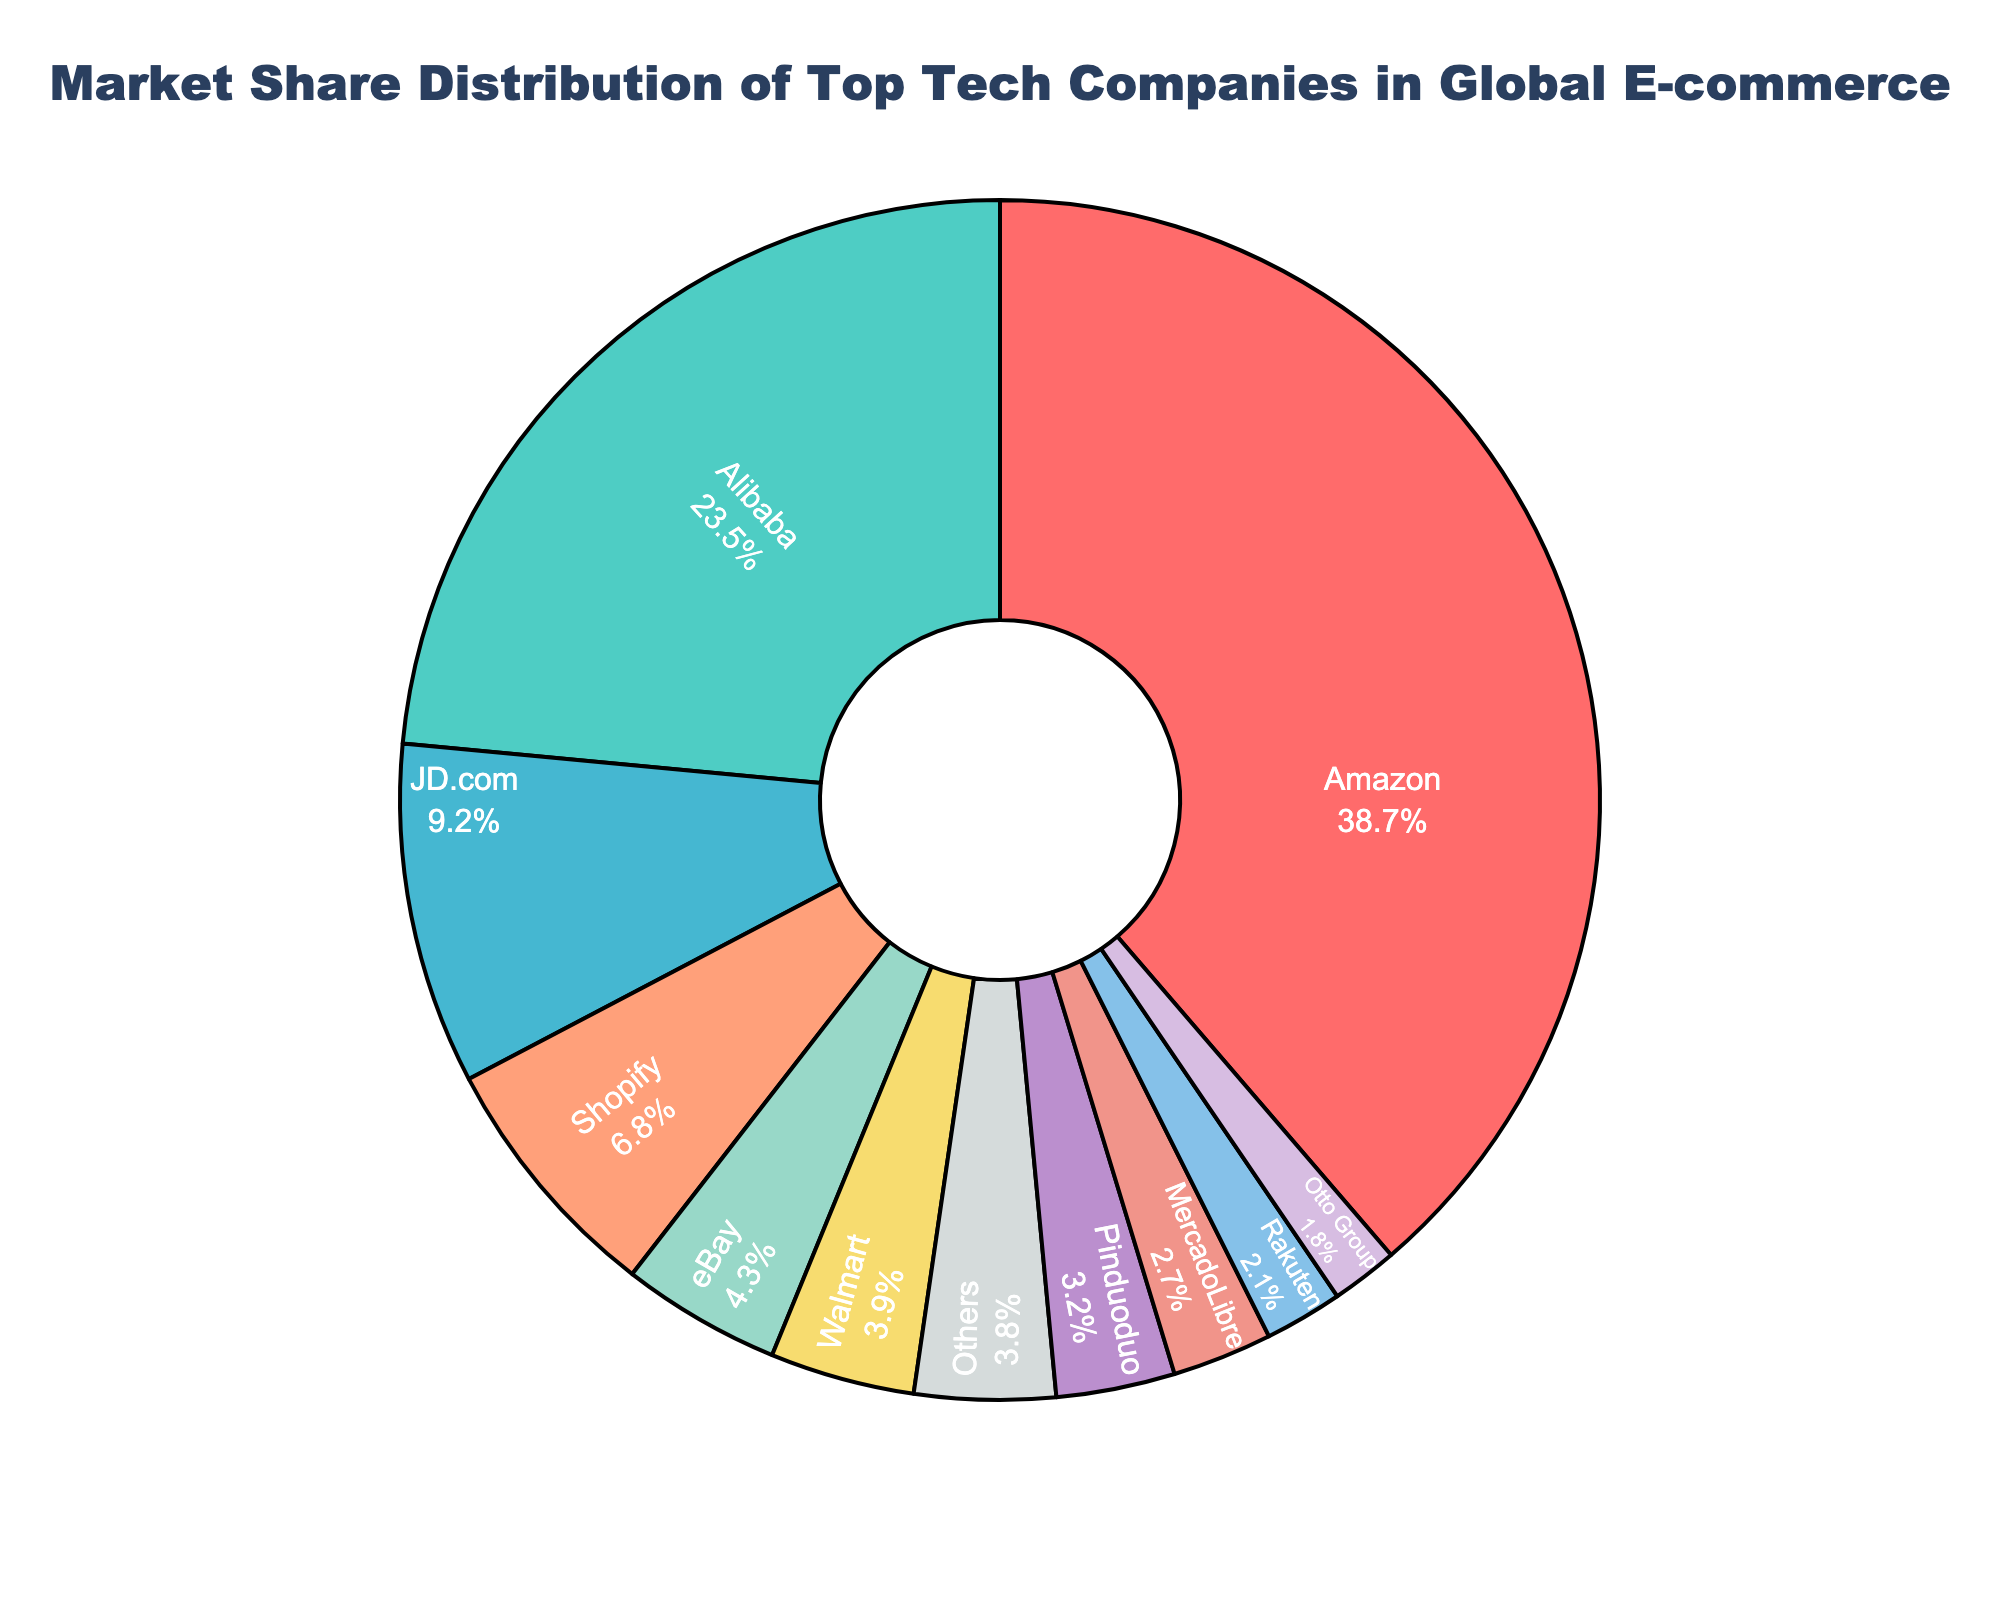Which company holds the largest market share in global e-commerce? Looking at the size of the slices in the pie chart, Amazon has the largest slice, indicating the highest market share.
Answer: Amazon What is the combined market share of JD.com, Shopify, and Pinduoduo? Add the market share percentages of JD.com (9.2%), Shopify (6.8%), and Pinduoduo (3.2%). The combined market share is 9.2 + 6.8 + 3.2 = 19.2%.
Answer: 19.2% How does eBay's market share compare to Walmart's market share? eBay's market share is 4.3%, while Walmart's market share is 3.9%. eBay's market share is marginally higher than Walmart's.
Answer: eBay has a higher market share than Walmart Is Alibaba's market share greater than the combined market share of MercadoLibre and Rakuten? Alibaba's market share is 23.5%. The combined market share of MercadoLibre (2.7%) and Rakuten (2.1%) is 4.8%. Alibaba's market share is significantly higher than the combined share of MercadoLibre and Rakuten.
Answer: Yes What is the market share of the companies categorized as 'Others'? The pie chart shows that 'Others' have a market share of 3.8%.
Answer: 3.8% What is the difference in market share between the largest company (Amazon) and the smallest company (Otto Group)? Amazon's market share is 38.7%, and Otto Group's market share is 1.8%. The difference is 38.7% - 1.8% = 36.9%.
Answer: 36.9% Which company has a smaller market share: Shopify or Pinduoduo? Shopify has a market share of 6.8%, whereas Pinduoduo has a market share of 3.2%. Therefore, Pinduoduo has a smaller market share than Shopify.
Answer: Pinduoduo What percentage of the market do the top three companies (Amazon, Alibaba, and JD.com) control? Add the market share percentages of Amazon (38.7%), Alibaba (23.5%), and JD.com (9.2%). The total market share controlled by the top three companies is 38.7% + 23.5% + 9.2% = 71.4%.
Answer: 71.4% Identify a company with a blue-colored slice in the pie chart and its market share. One of the blue-colored slices in the pie chart represents JD.com, which has a market share of 9.2%.
Answer: JD.com with 9.2% Compare the total market share of companies with a market share less than 3% to that of Walmart. Identify companies with <3% market share: MercadoLibre (2.7%), Rakuten (2.1%), Otto Group (1.8%). Their combined market share is 2.7% + 2.1% + 1.8% = 6.6%, which is greater than Walmart's market share of 3.9%.
Answer: The companies combined have a higher market share 